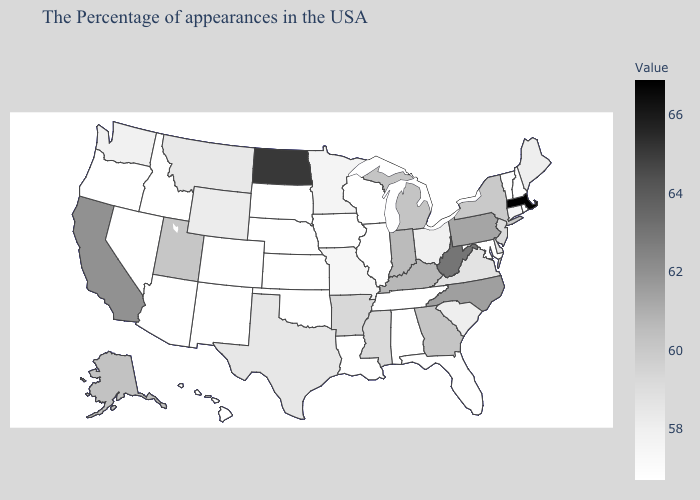Among the states that border Georgia , does Tennessee have the highest value?
Be succinct. No. Which states hav the highest value in the South?
Short answer required. West Virginia. Is the legend a continuous bar?
Concise answer only. Yes. Which states have the highest value in the USA?
Keep it brief. Massachusetts. 